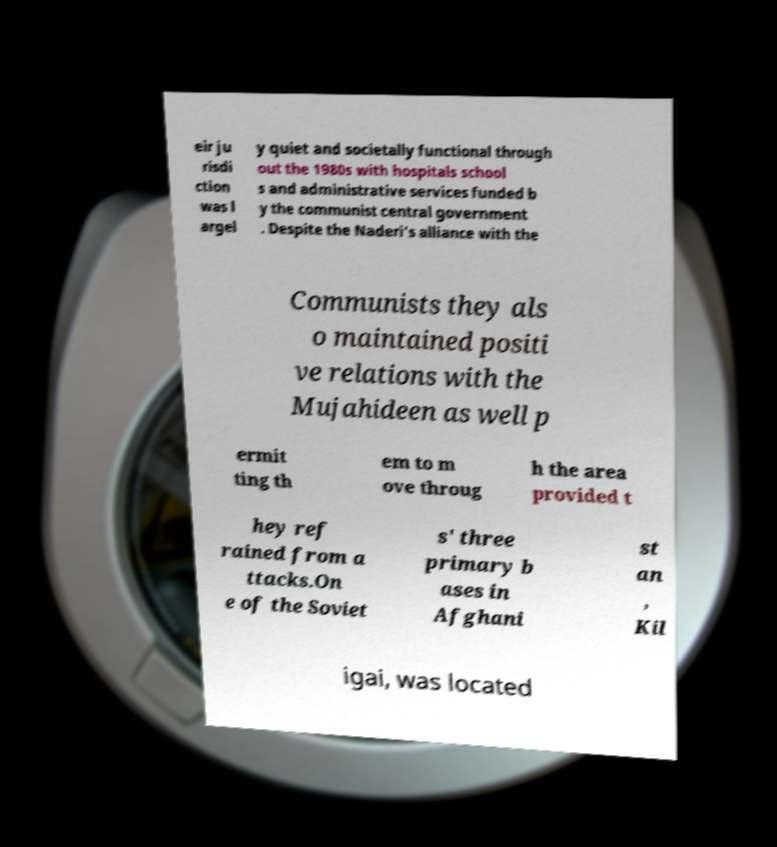Please read and relay the text visible in this image. What does it say? eir ju risdi ction was l argel y quiet and societally functional through out the 1980s with hospitals school s and administrative services funded b y the communist central government . Despite the Naderi's alliance with the Communists they als o maintained positi ve relations with the Mujahideen as well p ermit ting th em to m ove throug h the area provided t hey ref rained from a ttacks.On e of the Soviet s' three primary b ases in Afghani st an , Kil igai, was located 